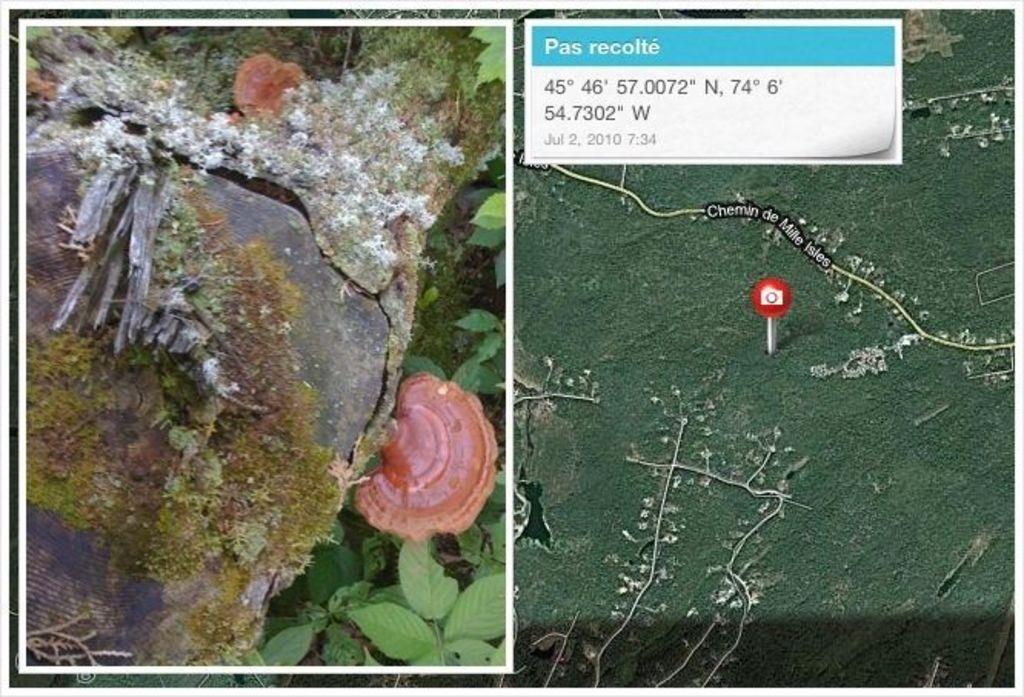How would you summarize this image in a sentence or two? In this picture I can observe two images. One of the images is a map. The other image is overlapped on the map. In the second image I can observe a stone and some plants. In the top of the picture I can observe location coordinates. 